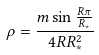<formula> <loc_0><loc_0><loc_500><loc_500>\rho = \frac { m \sin { \frac { R \pi } { R _ { * } } } } { 4 R R _ { * } ^ { 2 } }</formula> 